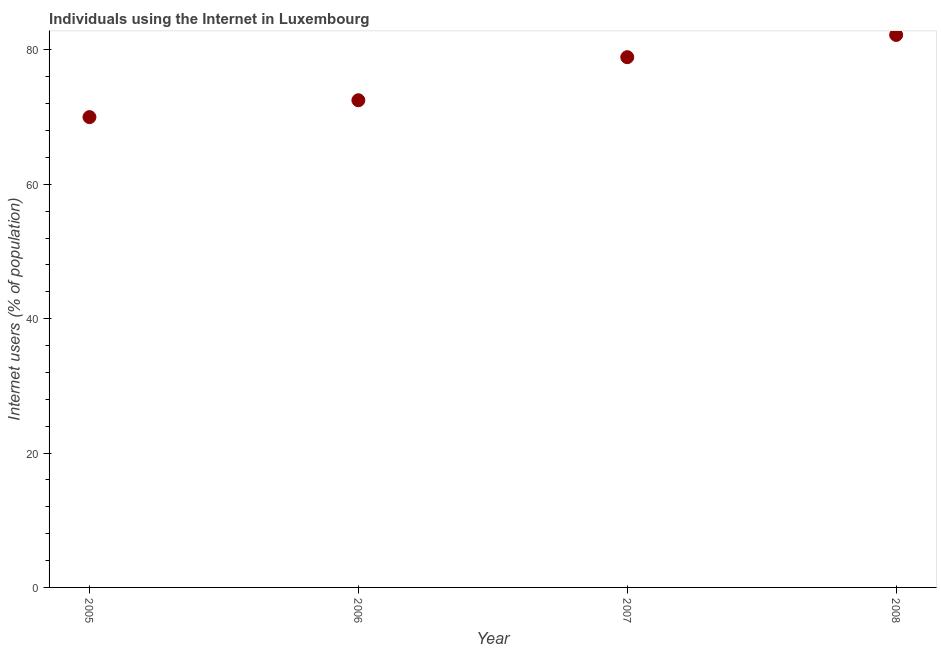Across all years, what is the maximum number of internet users?
Ensure brevity in your answer.  82.23. In which year was the number of internet users maximum?
Provide a short and direct response. 2008. What is the sum of the number of internet users?
Ensure brevity in your answer.  303.66. What is the difference between the number of internet users in 2005 and 2007?
Your answer should be very brief. -8.92. What is the average number of internet users per year?
Offer a very short reply. 75.92. What is the median number of internet users?
Your answer should be very brief. 75.72. What is the ratio of the number of internet users in 2007 to that in 2008?
Keep it short and to the point. 0.96. Is the difference between the number of internet users in 2005 and 2008 greater than the difference between any two years?
Your answer should be compact. Yes. What is the difference between the highest and the second highest number of internet users?
Give a very brief answer. 3.31. What is the difference between the highest and the lowest number of internet users?
Offer a terse response. 12.23. How many dotlines are there?
Ensure brevity in your answer.  1. What is the difference between two consecutive major ticks on the Y-axis?
Keep it short and to the point. 20. Are the values on the major ticks of Y-axis written in scientific E-notation?
Offer a terse response. No. What is the title of the graph?
Offer a terse response. Individuals using the Internet in Luxembourg. What is the label or title of the X-axis?
Offer a very short reply. Year. What is the label or title of the Y-axis?
Your answer should be very brief. Internet users (% of population). What is the Internet users (% of population) in 2006?
Provide a succinct answer. 72.51. What is the Internet users (% of population) in 2007?
Your answer should be very brief. 78.92. What is the Internet users (% of population) in 2008?
Ensure brevity in your answer.  82.23. What is the difference between the Internet users (% of population) in 2005 and 2006?
Your answer should be compact. -2.51. What is the difference between the Internet users (% of population) in 2005 and 2007?
Give a very brief answer. -8.92. What is the difference between the Internet users (% of population) in 2005 and 2008?
Make the answer very short. -12.23. What is the difference between the Internet users (% of population) in 2006 and 2007?
Give a very brief answer. -6.41. What is the difference between the Internet users (% of population) in 2006 and 2008?
Give a very brief answer. -9.72. What is the difference between the Internet users (% of population) in 2007 and 2008?
Your response must be concise. -3.31. What is the ratio of the Internet users (% of population) in 2005 to that in 2007?
Offer a terse response. 0.89. What is the ratio of the Internet users (% of population) in 2005 to that in 2008?
Provide a succinct answer. 0.85. What is the ratio of the Internet users (% of population) in 2006 to that in 2007?
Keep it short and to the point. 0.92. What is the ratio of the Internet users (% of population) in 2006 to that in 2008?
Keep it short and to the point. 0.88. 